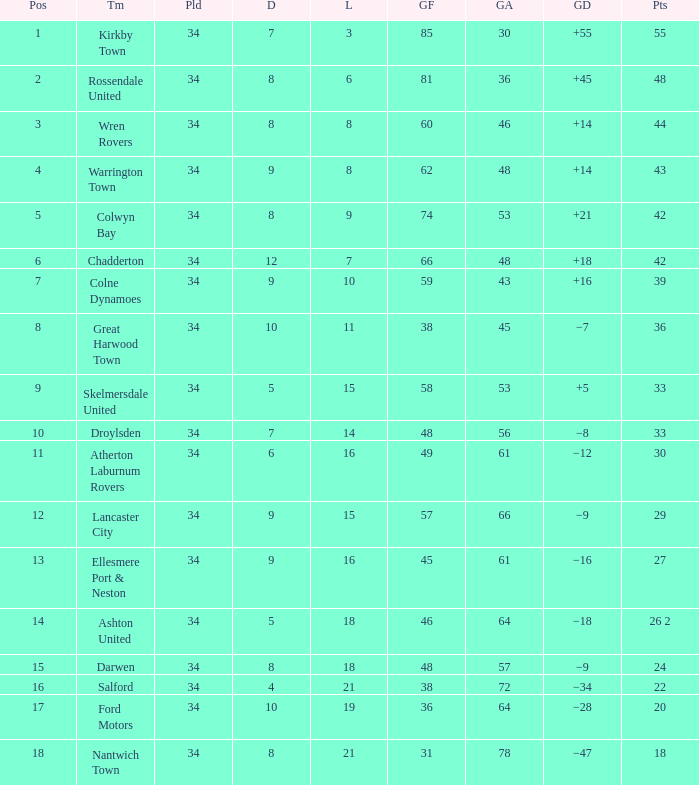Write the full table. {'header': ['Pos', 'Tm', 'Pld', 'D', 'L', 'GF', 'GA', 'GD', 'Pts'], 'rows': [['1', 'Kirkby Town', '34', '7', '3', '85', '30', '+55', '55'], ['2', 'Rossendale United', '34', '8', '6', '81', '36', '+45', '48'], ['3', 'Wren Rovers', '34', '8', '8', '60', '46', '+14', '44'], ['4', 'Warrington Town', '34', '9', '8', '62', '48', '+14', '43'], ['5', 'Colwyn Bay', '34', '8', '9', '74', '53', '+21', '42'], ['6', 'Chadderton', '34', '12', '7', '66', '48', '+18', '42'], ['7', 'Colne Dynamoes', '34', '9', '10', '59', '43', '+16', '39'], ['8', 'Great Harwood Town', '34', '10', '11', '38', '45', '−7', '36'], ['9', 'Skelmersdale United', '34', '5', '15', '58', '53', '+5', '33'], ['10', 'Droylsden', '34', '7', '14', '48', '56', '−8', '33'], ['11', 'Atherton Laburnum Rovers', '34', '6', '16', '49', '61', '−12', '30'], ['12', 'Lancaster City', '34', '9', '15', '57', '66', '−9', '29'], ['13', 'Ellesmere Port & Neston', '34', '9', '16', '45', '61', '−16', '27'], ['14', 'Ashton United', '34', '5', '18', '46', '64', '−18', '26 2'], ['15', 'Darwen', '34', '8', '18', '48', '57', '−9', '24'], ['16', 'Salford', '34', '4', '21', '38', '72', '−34', '22'], ['17', 'Ford Motors', '34', '10', '19', '36', '64', '−28', '20'], ['18', 'Nantwich Town', '34', '8', '21', '31', '78', '−47', '18']]} What is the total number of goals for when the drawn is less than 7, less than 21 games have been lost, and there are 1 of 33 points? 1.0. 